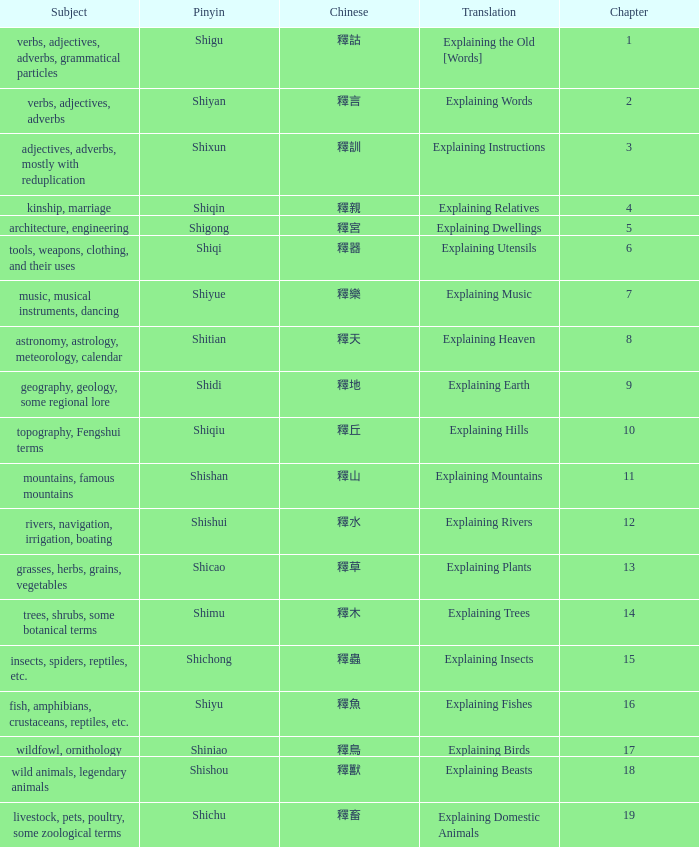Name the total number of chapter for chinese of 釋宮 1.0. 